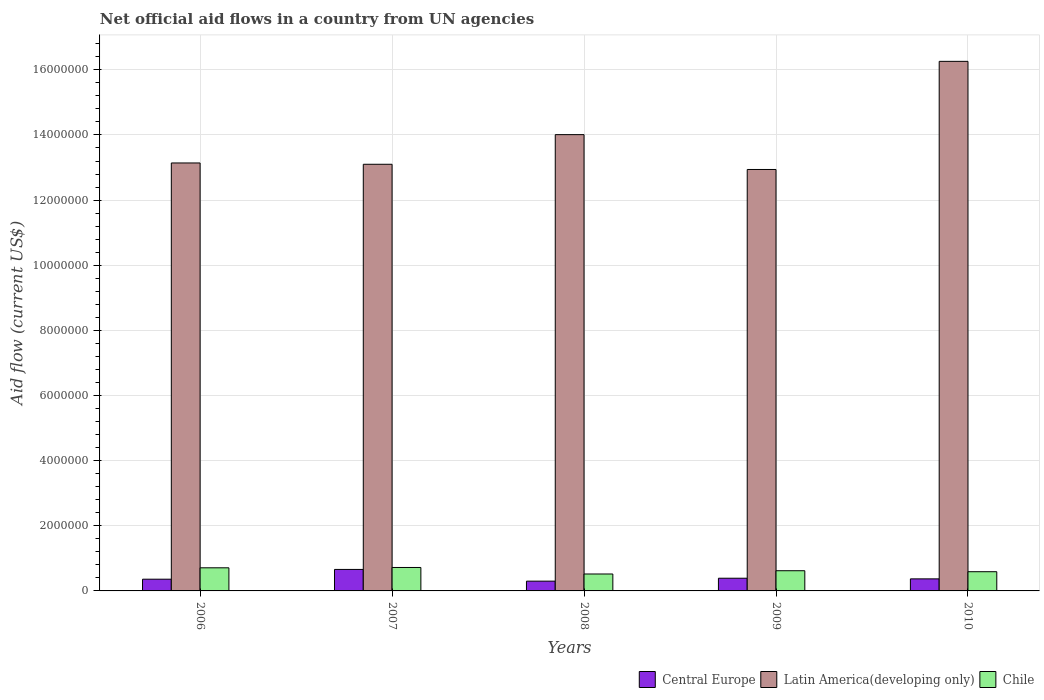How many different coloured bars are there?
Your answer should be compact. 3. How many groups of bars are there?
Provide a short and direct response. 5. Are the number of bars on each tick of the X-axis equal?
Your answer should be very brief. Yes. What is the net official aid flow in Latin America(developing only) in 2006?
Offer a terse response. 1.31e+07. Across all years, what is the maximum net official aid flow in Central Europe?
Your answer should be very brief. 6.60e+05. In which year was the net official aid flow in Chile maximum?
Offer a very short reply. 2007. What is the total net official aid flow in Central Europe in the graph?
Provide a short and direct response. 2.08e+06. What is the difference between the net official aid flow in Chile in 2007 and that in 2008?
Provide a succinct answer. 2.00e+05. What is the difference between the net official aid flow in Central Europe in 2007 and the net official aid flow in Chile in 2006?
Offer a very short reply. -5.00e+04. What is the average net official aid flow in Central Europe per year?
Your answer should be very brief. 4.16e+05. In the year 2006, what is the difference between the net official aid flow in Central Europe and net official aid flow in Latin America(developing only)?
Provide a succinct answer. -1.28e+07. In how many years, is the net official aid flow in Latin America(developing only) greater than 2000000 US$?
Offer a very short reply. 5. What is the ratio of the net official aid flow in Latin America(developing only) in 2006 to that in 2008?
Keep it short and to the point. 0.94. Is the net official aid flow in Latin America(developing only) in 2006 less than that in 2007?
Offer a very short reply. No. What is the difference between the highest and the second highest net official aid flow in Latin America(developing only)?
Make the answer very short. 2.25e+06. What is the difference between the highest and the lowest net official aid flow in Latin America(developing only)?
Keep it short and to the point. 3.32e+06. Is the sum of the net official aid flow in Central Europe in 2006 and 2007 greater than the maximum net official aid flow in Latin America(developing only) across all years?
Your answer should be compact. No. What does the 1st bar from the left in 2008 represents?
Your answer should be very brief. Central Europe. Is it the case that in every year, the sum of the net official aid flow in Chile and net official aid flow in Central Europe is greater than the net official aid flow in Latin America(developing only)?
Give a very brief answer. No. Are the values on the major ticks of Y-axis written in scientific E-notation?
Make the answer very short. No. Does the graph contain any zero values?
Your answer should be compact. No. How many legend labels are there?
Your response must be concise. 3. What is the title of the graph?
Provide a short and direct response. Net official aid flows in a country from UN agencies. What is the label or title of the Y-axis?
Offer a very short reply. Aid flow (current US$). What is the Aid flow (current US$) of Latin America(developing only) in 2006?
Give a very brief answer. 1.31e+07. What is the Aid flow (current US$) of Chile in 2006?
Ensure brevity in your answer.  7.10e+05. What is the Aid flow (current US$) of Central Europe in 2007?
Provide a short and direct response. 6.60e+05. What is the Aid flow (current US$) in Latin America(developing only) in 2007?
Provide a succinct answer. 1.31e+07. What is the Aid flow (current US$) of Chile in 2007?
Keep it short and to the point. 7.20e+05. What is the Aid flow (current US$) of Latin America(developing only) in 2008?
Your answer should be compact. 1.40e+07. What is the Aid flow (current US$) in Chile in 2008?
Ensure brevity in your answer.  5.20e+05. What is the Aid flow (current US$) of Latin America(developing only) in 2009?
Provide a succinct answer. 1.29e+07. What is the Aid flow (current US$) of Chile in 2009?
Your answer should be compact. 6.20e+05. What is the Aid flow (current US$) in Central Europe in 2010?
Keep it short and to the point. 3.70e+05. What is the Aid flow (current US$) in Latin America(developing only) in 2010?
Provide a short and direct response. 1.63e+07. What is the Aid flow (current US$) of Chile in 2010?
Ensure brevity in your answer.  5.90e+05. Across all years, what is the maximum Aid flow (current US$) of Latin America(developing only)?
Your answer should be compact. 1.63e+07. Across all years, what is the maximum Aid flow (current US$) in Chile?
Ensure brevity in your answer.  7.20e+05. Across all years, what is the minimum Aid flow (current US$) of Latin America(developing only)?
Provide a succinct answer. 1.29e+07. Across all years, what is the minimum Aid flow (current US$) of Chile?
Your answer should be compact. 5.20e+05. What is the total Aid flow (current US$) in Central Europe in the graph?
Make the answer very short. 2.08e+06. What is the total Aid flow (current US$) of Latin America(developing only) in the graph?
Give a very brief answer. 6.94e+07. What is the total Aid flow (current US$) of Chile in the graph?
Your answer should be very brief. 3.16e+06. What is the difference between the Aid flow (current US$) in Central Europe in 2006 and that in 2007?
Offer a terse response. -3.00e+05. What is the difference between the Aid flow (current US$) in Latin America(developing only) in 2006 and that in 2007?
Ensure brevity in your answer.  4.00e+04. What is the difference between the Aid flow (current US$) of Chile in 2006 and that in 2007?
Offer a terse response. -10000. What is the difference between the Aid flow (current US$) of Latin America(developing only) in 2006 and that in 2008?
Ensure brevity in your answer.  -8.70e+05. What is the difference between the Aid flow (current US$) of Chile in 2006 and that in 2008?
Offer a very short reply. 1.90e+05. What is the difference between the Aid flow (current US$) in Central Europe in 2006 and that in 2009?
Ensure brevity in your answer.  -3.00e+04. What is the difference between the Aid flow (current US$) of Central Europe in 2006 and that in 2010?
Give a very brief answer. -10000. What is the difference between the Aid flow (current US$) of Latin America(developing only) in 2006 and that in 2010?
Your response must be concise. -3.12e+06. What is the difference between the Aid flow (current US$) in Chile in 2006 and that in 2010?
Make the answer very short. 1.20e+05. What is the difference between the Aid flow (current US$) in Latin America(developing only) in 2007 and that in 2008?
Offer a terse response. -9.10e+05. What is the difference between the Aid flow (current US$) in Central Europe in 2007 and that in 2009?
Give a very brief answer. 2.70e+05. What is the difference between the Aid flow (current US$) of Latin America(developing only) in 2007 and that in 2009?
Your answer should be very brief. 1.60e+05. What is the difference between the Aid flow (current US$) in Latin America(developing only) in 2007 and that in 2010?
Your answer should be very brief. -3.16e+06. What is the difference between the Aid flow (current US$) in Chile in 2007 and that in 2010?
Provide a short and direct response. 1.30e+05. What is the difference between the Aid flow (current US$) in Central Europe in 2008 and that in 2009?
Offer a terse response. -9.00e+04. What is the difference between the Aid flow (current US$) in Latin America(developing only) in 2008 and that in 2009?
Provide a short and direct response. 1.07e+06. What is the difference between the Aid flow (current US$) of Chile in 2008 and that in 2009?
Offer a very short reply. -1.00e+05. What is the difference between the Aid flow (current US$) in Central Europe in 2008 and that in 2010?
Your response must be concise. -7.00e+04. What is the difference between the Aid flow (current US$) in Latin America(developing only) in 2008 and that in 2010?
Your answer should be very brief. -2.25e+06. What is the difference between the Aid flow (current US$) in Chile in 2008 and that in 2010?
Offer a very short reply. -7.00e+04. What is the difference between the Aid flow (current US$) in Latin America(developing only) in 2009 and that in 2010?
Offer a very short reply. -3.32e+06. What is the difference between the Aid flow (current US$) in Chile in 2009 and that in 2010?
Keep it short and to the point. 3.00e+04. What is the difference between the Aid flow (current US$) in Central Europe in 2006 and the Aid flow (current US$) in Latin America(developing only) in 2007?
Provide a succinct answer. -1.27e+07. What is the difference between the Aid flow (current US$) in Central Europe in 2006 and the Aid flow (current US$) in Chile in 2007?
Offer a very short reply. -3.60e+05. What is the difference between the Aid flow (current US$) of Latin America(developing only) in 2006 and the Aid flow (current US$) of Chile in 2007?
Keep it short and to the point. 1.24e+07. What is the difference between the Aid flow (current US$) in Central Europe in 2006 and the Aid flow (current US$) in Latin America(developing only) in 2008?
Make the answer very short. -1.36e+07. What is the difference between the Aid flow (current US$) in Latin America(developing only) in 2006 and the Aid flow (current US$) in Chile in 2008?
Give a very brief answer. 1.26e+07. What is the difference between the Aid flow (current US$) of Central Europe in 2006 and the Aid flow (current US$) of Latin America(developing only) in 2009?
Ensure brevity in your answer.  -1.26e+07. What is the difference between the Aid flow (current US$) of Central Europe in 2006 and the Aid flow (current US$) of Chile in 2009?
Offer a terse response. -2.60e+05. What is the difference between the Aid flow (current US$) in Latin America(developing only) in 2006 and the Aid flow (current US$) in Chile in 2009?
Your response must be concise. 1.25e+07. What is the difference between the Aid flow (current US$) of Central Europe in 2006 and the Aid flow (current US$) of Latin America(developing only) in 2010?
Keep it short and to the point. -1.59e+07. What is the difference between the Aid flow (current US$) of Central Europe in 2006 and the Aid flow (current US$) of Chile in 2010?
Give a very brief answer. -2.30e+05. What is the difference between the Aid flow (current US$) in Latin America(developing only) in 2006 and the Aid flow (current US$) in Chile in 2010?
Your response must be concise. 1.26e+07. What is the difference between the Aid flow (current US$) in Central Europe in 2007 and the Aid flow (current US$) in Latin America(developing only) in 2008?
Your answer should be compact. -1.34e+07. What is the difference between the Aid flow (current US$) of Latin America(developing only) in 2007 and the Aid flow (current US$) of Chile in 2008?
Your answer should be very brief. 1.26e+07. What is the difference between the Aid flow (current US$) of Central Europe in 2007 and the Aid flow (current US$) of Latin America(developing only) in 2009?
Provide a succinct answer. -1.23e+07. What is the difference between the Aid flow (current US$) of Latin America(developing only) in 2007 and the Aid flow (current US$) of Chile in 2009?
Your response must be concise. 1.25e+07. What is the difference between the Aid flow (current US$) in Central Europe in 2007 and the Aid flow (current US$) in Latin America(developing only) in 2010?
Offer a terse response. -1.56e+07. What is the difference between the Aid flow (current US$) in Latin America(developing only) in 2007 and the Aid flow (current US$) in Chile in 2010?
Keep it short and to the point. 1.25e+07. What is the difference between the Aid flow (current US$) of Central Europe in 2008 and the Aid flow (current US$) of Latin America(developing only) in 2009?
Give a very brief answer. -1.26e+07. What is the difference between the Aid flow (current US$) of Central Europe in 2008 and the Aid flow (current US$) of Chile in 2009?
Your answer should be very brief. -3.20e+05. What is the difference between the Aid flow (current US$) in Latin America(developing only) in 2008 and the Aid flow (current US$) in Chile in 2009?
Your answer should be very brief. 1.34e+07. What is the difference between the Aid flow (current US$) of Central Europe in 2008 and the Aid flow (current US$) of Latin America(developing only) in 2010?
Keep it short and to the point. -1.60e+07. What is the difference between the Aid flow (current US$) of Central Europe in 2008 and the Aid flow (current US$) of Chile in 2010?
Offer a very short reply. -2.90e+05. What is the difference between the Aid flow (current US$) in Latin America(developing only) in 2008 and the Aid flow (current US$) in Chile in 2010?
Keep it short and to the point. 1.34e+07. What is the difference between the Aid flow (current US$) of Central Europe in 2009 and the Aid flow (current US$) of Latin America(developing only) in 2010?
Offer a very short reply. -1.59e+07. What is the difference between the Aid flow (current US$) in Central Europe in 2009 and the Aid flow (current US$) in Chile in 2010?
Ensure brevity in your answer.  -2.00e+05. What is the difference between the Aid flow (current US$) in Latin America(developing only) in 2009 and the Aid flow (current US$) in Chile in 2010?
Provide a short and direct response. 1.24e+07. What is the average Aid flow (current US$) in Central Europe per year?
Ensure brevity in your answer.  4.16e+05. What is the average Aid flow (current US$) of Latin America(developing only) per year?
Keep it short and to the point. 1.39e+07. What is the average Aid flow (current US$) in Chile per year?
Your answer should be very brief. 6.32e+05. In the year 2006, what is the difference between the Aid flow (current US$) in Central Europe and Aid flow (current US$) in Latin America(developing only)?
Your answer should be compact. -1.28e+07. In the year 2006, what is the difference between the Aid flow (current US$) in Central Europe and Aid flow (current US$) in Chile?
Keep it short and to the point. -3.50e+05. In the year 2006, what is the difference between the Aid flow (current US$) in Latin America(developing only) and Aid flow (current US$) in Chile?
Ensure brevity in your answer.  1.24e+07. In the year 2007, what is the difference between the Aid flow (current US$) of Central Europe and Aid flow (current US$) of Latin America(developing only)?
Offer a terse response. -1.24e+07. In the year 2007, what is the difference between the Aid flow (current US$) in Latin America(developing only) and Aid flow (current US$) in Chile?
Your answer should be very brief. 1.24e+07. In the year 2008, what is the difference between the Aid flow (current US$) in Central Europe and Aid flow (current US$) in Latin America(developing only)?
Give a very brief answer. -1.37e+07. In the year 2008, what is the difference between the Aid flow (current US$) of Latin America(developing only) and Aid flow (current US$) of Chile?
Your response must be concise. 1.35e+07. In the year 2009, what is the difference between the Aid flow (current US$) in Central Europe and Aid flow (current US$) in Latin America(developing only)?
Your response must be concise. -1.26e+07. In the year 2009, what is the difference between the Aid flow (current US$) in Latin America(developing only) and Aid flow (current US$) in Chile?
Keep it short and to the point. 1.23e+07. In the year 2010, what is the difference between the Aid flow (current US$) in Central Europe and Aid flow (current US$) in Latin America(developing only)?
Provide a short and direct response. -1.59e+07. In the year 2010, what is the difference between the Aid flow (current US$) of Central Europe and Aid flow (current US$) of Chile?
Ensure brevity in your answer.  -2.20e+05. In the year 2010, what is the difference between the Aid flow (current US$) of Latin America(developing only) and Aid flow (current US$) of Chile?
Ensure brevity in your answer.  1.57e+07. What is the ratio of the Aid flow (current US$) in Central Europe in 2006 to that in 2007?
Make the answer very short. 0.55. What is the ratio of the Aid flow (current US$) of Latin America(developing only) in 2006 to that in 2007?
Offer a terse response. 1. What is the ratio of the Aid flow (current US$) of Chile in 2006 to that in 2007?
Provide a succinct answer. 0.99. What is the ratio of the Aid flow (current US$) of Central Europe in 2006 to that in 2008?
Offer a very short reply. 1.2. What is the ratio of the Aid flow (current US$) in Latin America(developing only) in 2006 to that in 2008?
Give a very brief answer. 0.94. What is the ratio of the Aid flow (current US$) of Chile in 2006 to that in 2008?
Ensure brevity in your answer.  1.37. What is the ratio of the Aid flow (current US$) of Latin America(developing only) in 2006 to that in 2009?
Keep it short and to the point. 1.02. What is the ratio of the Aid flow (current US$) in Chile in 2006 to that in 2009?
Make the answer very short. 1.15. What is the ratio of the Aid flow (current US$) of Latin America(developing only) in 2006 to that in 2010?
Your answer should be compact. 0.81. What is the ratio of the Aid flow (current US$) in Chile in 2006 to that in 2010?
Your response must be concise. 1.2. What is the ratio of the Aid flow (current US$) of Latin America(developing only) in 2007 to that in 2008?
Offer a very short reply. 0.94. What is the ratio of the Aid flow (current US$) in Chile in 2007 to that in 2008?
Your answer should be compact. 1.38. What is the ratio of the Aid flow (current US$) of Central Europe in 2007 to that in 2009?
Provide a short and direct response. 1.69. What is the ratio of the Aid flow (current US$) of Latin America(developing only) in 2007 to that in 2009?
Offer a very short reply. 1.01. What is the ratio of the Aid flow (current US$) of Chile in 2007 to that in 2009?
Your answer should be compact. 1.16. What is the ratio of the Aid flow (current US$) in Central Europe in 2007 to that in 2010?
Your answer should be compact. 1.78. What is the ratio of the Aid flow (current US$) in Latin America(developing only) in 2007 to that in 2010?
Give a very brief answer. 0.81. What is the ratio of the Aid flow (current US$) of Chile in 2007 to that in 2010?
Offer a terse response. 1.22. What is the ratio of the Aid flow (current US$) of Central Europe in 2008 to that in 2009?
Provide a succinct answer. 0.77. What is the ratio of the Aid flow (current US$) of Latin America(developing only) in 2008 to that in 2009?
Ensure brevity in your answer.  1.08. What is the ratio of the Aid flow (current US$) in Chile in 2008 to that in 2009?
Provide a succinct answer. 0.84. What is the ratio of the Aid flow (current US$) in Central Europe in 2008 to that in 2010?
Provide a succinct answer. 0.81. What is the ratio of the Aid flow (current US$) in Latin America(developing only) in 2008 to that in 2010?
Keep it short and to the point. 0.86. What is the ratio of the Aid flow (current US$) of Chile in 2008 to that in 2010?
Offer a very short reply. 0.88. What is the ratio of the Aid flow (current US$) in Central Europe in 2009 to that in 2010?
Provide a short and direct response. 1.05. What is the ratio of the Aid flow (current US$) of Latin America(developing only) in 2009 to that in 2010?
Provide a short and direct response. 0.8. What is the ratio of the Aid flow (current US$) in Chile in 2009 to that in 2010?
Provide a short and direct response. 1.05. What is the difference between the highest and the second highest Aid flow (current US$) in Central Europe?
Your response must be concise. 2.70e+05. What is the difference between the highest and the second highest Aid flow (current US$) of Latin America(developing only)?
Give a very brief answer. 2.25e+06. What is the difference between the highest and the second highest Aid flow (current US$) in Chile?
Give a very brief answer. 10000. What is the difference between the highest and the lowest Aid flow (current US$) in Central Europe?
Offer a very short reply. 3.60e+05. What is the difference between the highest and the lowest Aid flow (current US$) in Latin America(developing only)?
Provide a succinct answer. 3.32e+06. 